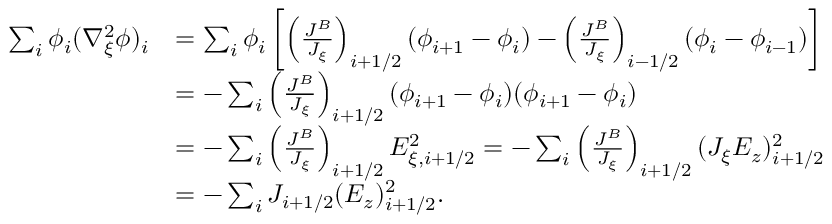Convert formula to latex. <formula><loc_0><loc_0><loc_500><loc_500>\begin{array} { r l } { \sum _ { i } \phi _ { i } ( \nabla _ { \xi } ^ { 2 } \phi ) _ { i } } & { = \sum _ { i } \phi _ { i } \left [ \left ( \frac { J ^ { B } } { J _ { \xi } } \right ) _ { i + 1 / 2 } ( \phi _ { i + 1 } - \phi _ { i } ) - \left ( \frac { J ^ { B } } { J _ { \xi } } \right ) _ { i - 1 / 2 } ( \phi _ { i } - \phi _ { i - 1 } ) \right ] } \\ & { = - \sum _ { i } \left ( \frac { J ^ { B } } { J _ { \xi } } \right ) _ { i + 1 / 2 } ( \phi _ { i + 1 } - \phi _ { i } ) ( \phi _ { i + 1 } - \phi _ { i } ) } \\ & { = - \sum _ { i } \left ( \frac { J ^ { B } } { J _ { \xi } } \right ) _ { i + 1 / 2 } E _ { \xi , i + 1 / 2 } ^ { 2 } = - \sum _ { i } \left ( \frac { J ^ { B } } { J _ { \xi } } \right ) _ { i + 1 / 2 } ( J _ { \xi } { E _ { z } } ) _ { i + 1 / 2 } ^ { 2 } } \\ & { = - \sum _ { i } J _ { i + 1 / 2 } ( { E _ { z } } ) _ { i + 1 / 2 } ^ { 2 } . } \end{array}</formula> 